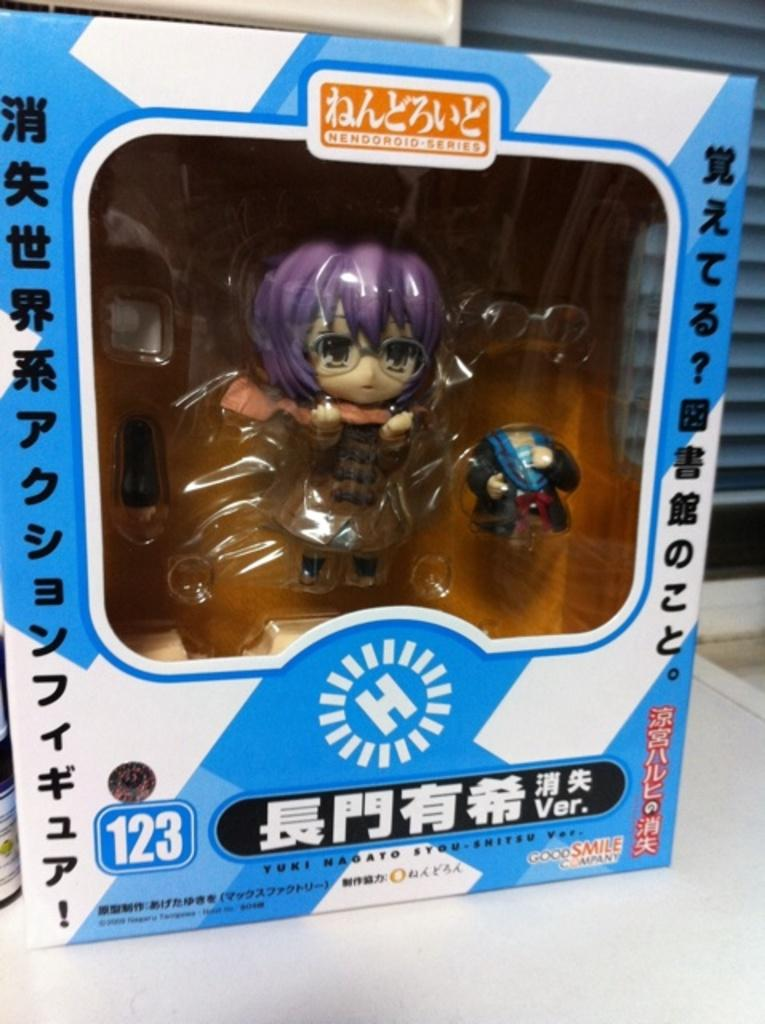What is the main subject of the image? The main subject of the image is a packet of toys. Where is the packet of toys located? The packet of toys is placed on a table. What type of health advice can be found in the image? There is no health advice present in the image; it features a packet of toys placed on a table. Can you tell me how many farmers are visible in the image? There are no farmers visible in the image; it features a packet of toys placed on a table. 